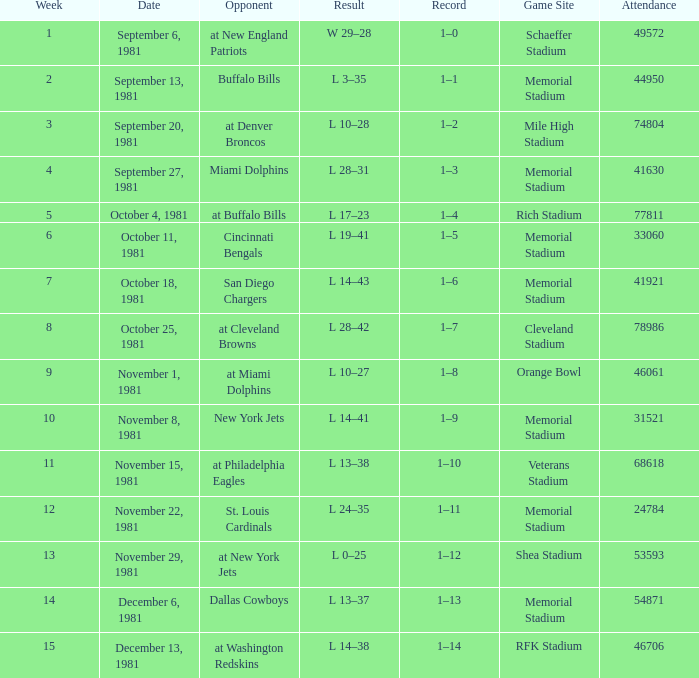When 74804 is the attendance what week is it? 3.0. 